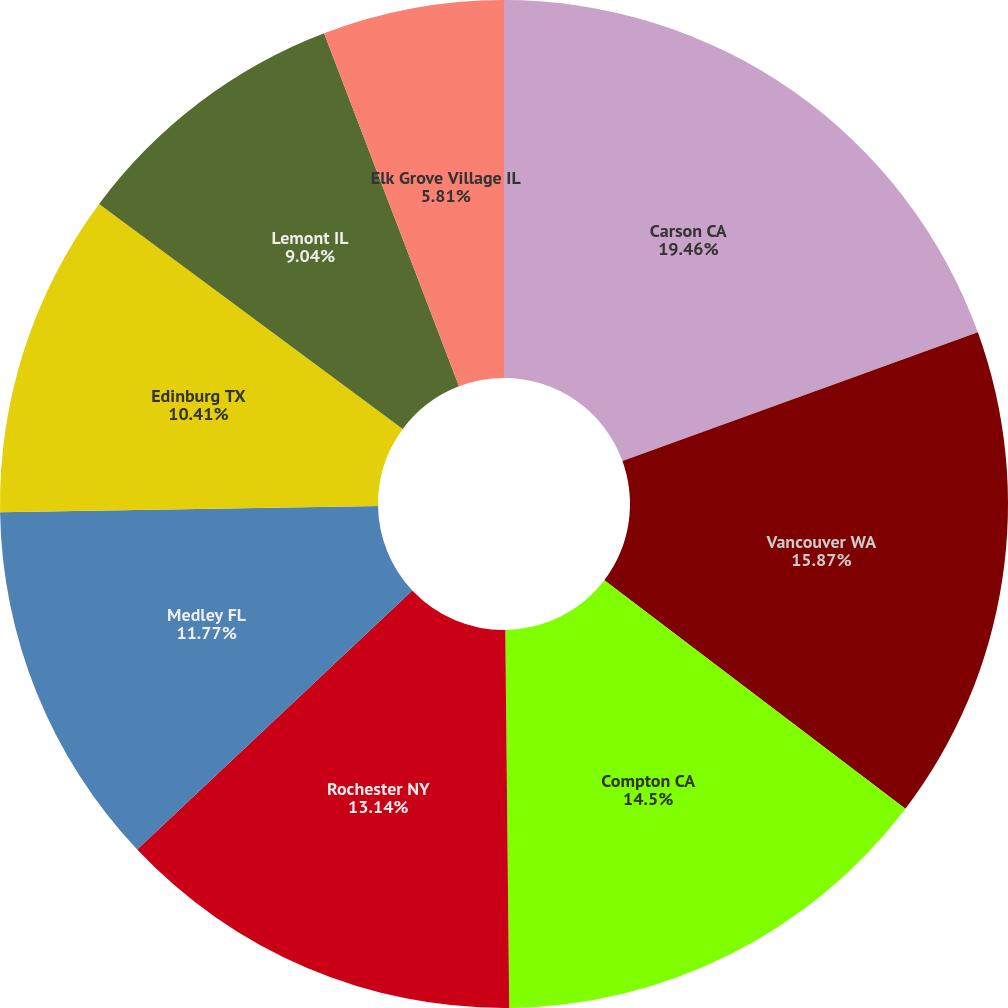Convert chart to OTSL. <chart><loc_0><loc_0><loc_500><loc_500><pie_chart><fcel>Carson CA<fcel>Vancouver WA<fcel>Compton CA<fcel>Rochester NY<fcel>Medley FL<fcel>Edinburg TX<fcel>Lemont IL<fcel>Elk Grove Village IL<nl><fcel>19.47%<fcel>15.87%<fcel>14.5%<fcel>13.14%<fcel>11.77%<fcel>10.41%<fcel>9.04%<fcel>5.81%<nl></chart> 